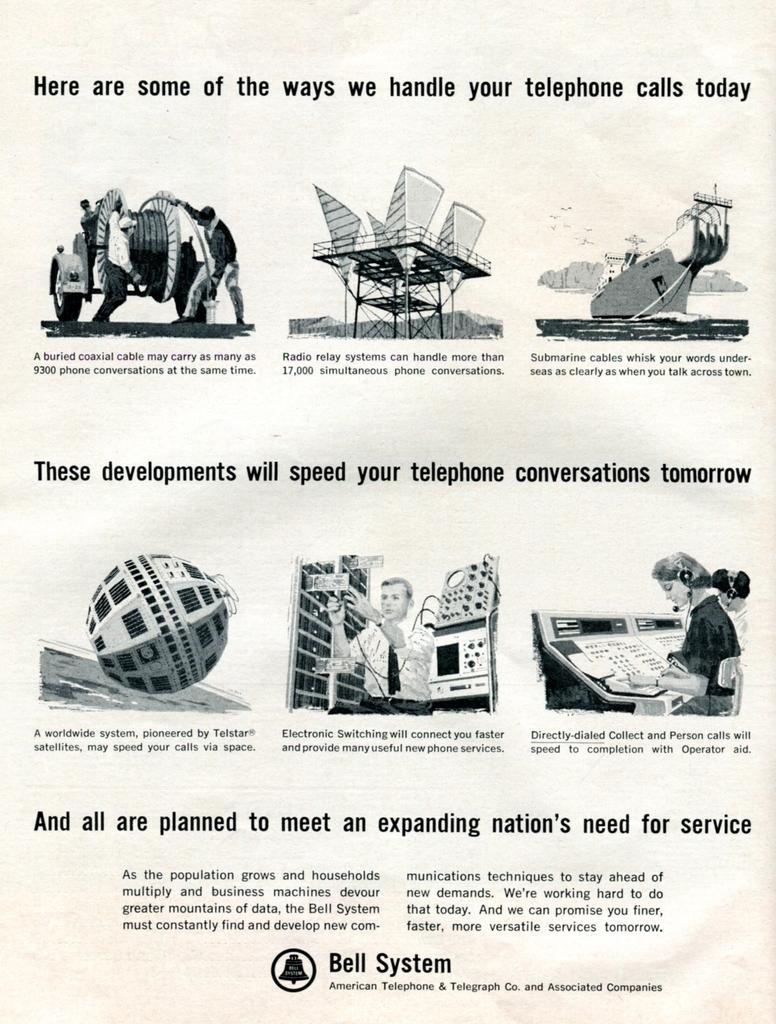Could you give a brief overview of what you see in this image? In this picture we can see the images of people and some objects on the paper. On the paper, it is written something. 